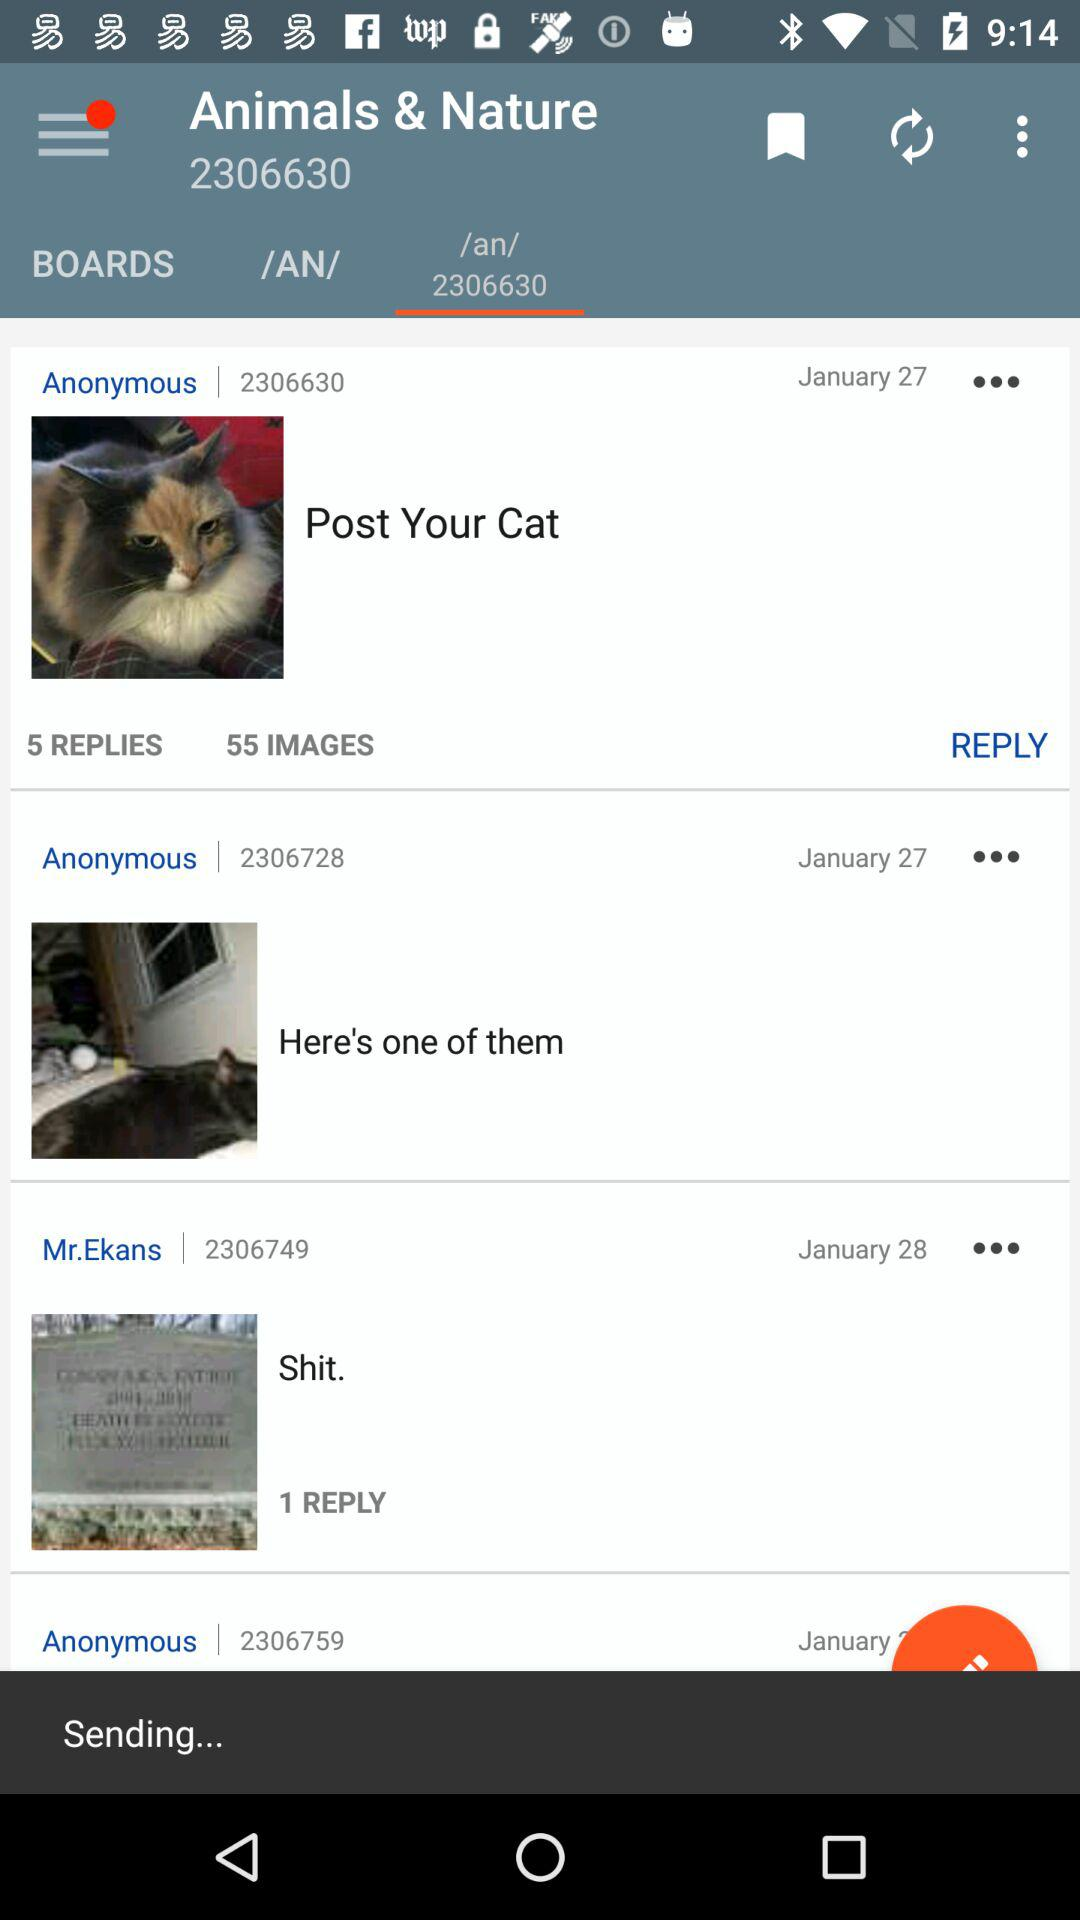How many replies are there for "Shit"? There is 1 reply. 